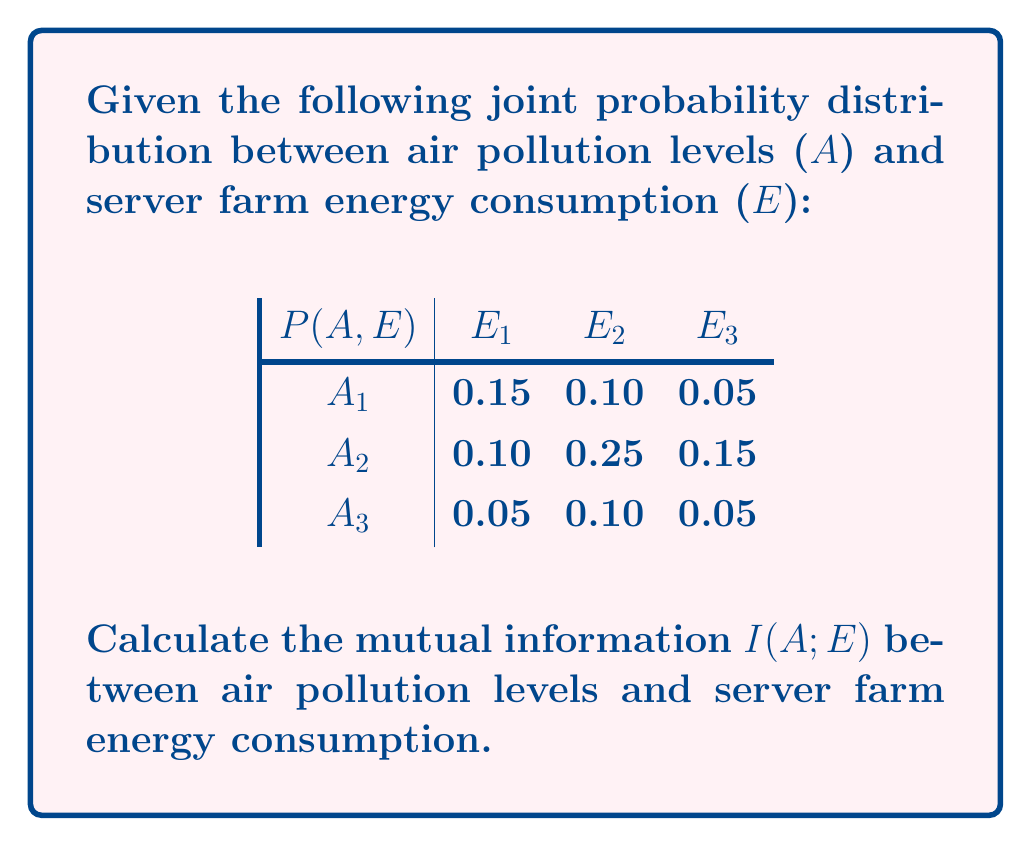Teach me how to tackle this problem. To calculate the mutual information $I(A;E)$, we need to follow these steps:

1. Calculate the marginal probabilities $P(A)$ and $P(E)$:

   $P(A_1) = 0.15 + 0.10 + 0.05 = 0.30$
   $P(A_2) = 0.10 + 0.25 + 0.15 = 0.50$
   $P(A_3) = 0.05 + 0.10 + 0.05 = 0.20$

   $P(E_1) = 0.15 + 0.10 + 0.05 = 0.30$
   $P(E_2) = 0.10 + 0.25 + 0.10 = 0.45$
   $P(E_3) = 0.05 + 0.15 + 0.05 = 0.25$

2. Use the formula for mutual information:

   $$I(A;E) = \sum_{a \in A} \sum_{e \in E} P(a,e) \log_2 \frac{P(a,e)}{P(a)P(e)}$$

3. Calculate each term of the summation:

   $0.15 \log_2 \frac{0.15}{0.30 \cdot 0.30} = 0.15 \log_2 1.6667 = 0.0744$
   $0.10 \log_2 \frac{0.10}{0.30 \cdot 0.45} = 0.10 \log_2 0.7407 = -0.0378$
   $0.05 \log_2 \frac{0.05}{0.30 \cdot 0.25} = 0.05 \log_2 0.6667 = -0.0237$
   $0.10 \log_2 \frac{0.10}{0.50 \cdot 0.30} = 0.10 \log_2 0.6667 = -0.0474$
   $0.25 \log_2 \frac{0.25}{0.50 \cdot 0.45} = 0.25 \log_2 1.1111 = 0.0263$
   $0.15 \log_2 \frac{0.15}{0.50 \cdot 0.25} = 0.15 \log_2 1.2000 = 0.0373$
   $0.05 \log_2 \frac{0.05}{0.20 \cdot 0.30} = 0.05 \log_2 0.8333 = -0.0103$
   $0.10 \log_2 \frac{0.10}{0.20 \cdot 0.45} = 0.10 \log_2 1.1111 = 0.0105$
   $0.05 \log_2 \frac{0.05}{0.20 \cdot 0.25} = 0.05 \log_2 1.0000 = 0$

4. Sum all the terms:

   $I(A;E) = 0.0744 - 0.0378 - 0.0237 - 0.0474 + 0.0263 + 0.0373 - 0.0103 + 0.0105 + 0$
           $= 0.0293$ bits
Answer: The mutual information $I(A;E)$ between air pollution levels and server farm energy consumption is approximately 0.0293 bits. 